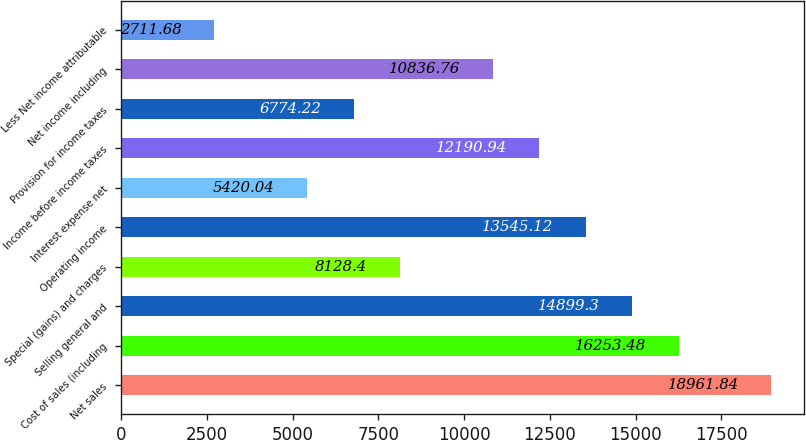Convert chart. <chart><loc_0><loc_0><loc_500><loc_500><bar_chart><fcel>Net sales<fcel>Cost of sales (including<fcel>Selling general and<fcel>Special (gains) and charges<fcel>Operating income<fcel>Interest expense net<fcel>Income before income taxes<fcel>Provision for income taxes<fcel>Net income including<fcel>Less Net income attributable<nl><fcel>18961.8<fcel>16253.5<fcel>14899.3<fcel>8128.4<fcel>13545.1<fcel>5420.04<fcel>12190.9<fcel>6774.22<fcel>10836.8<fcel>2711.68<nl></chart> 